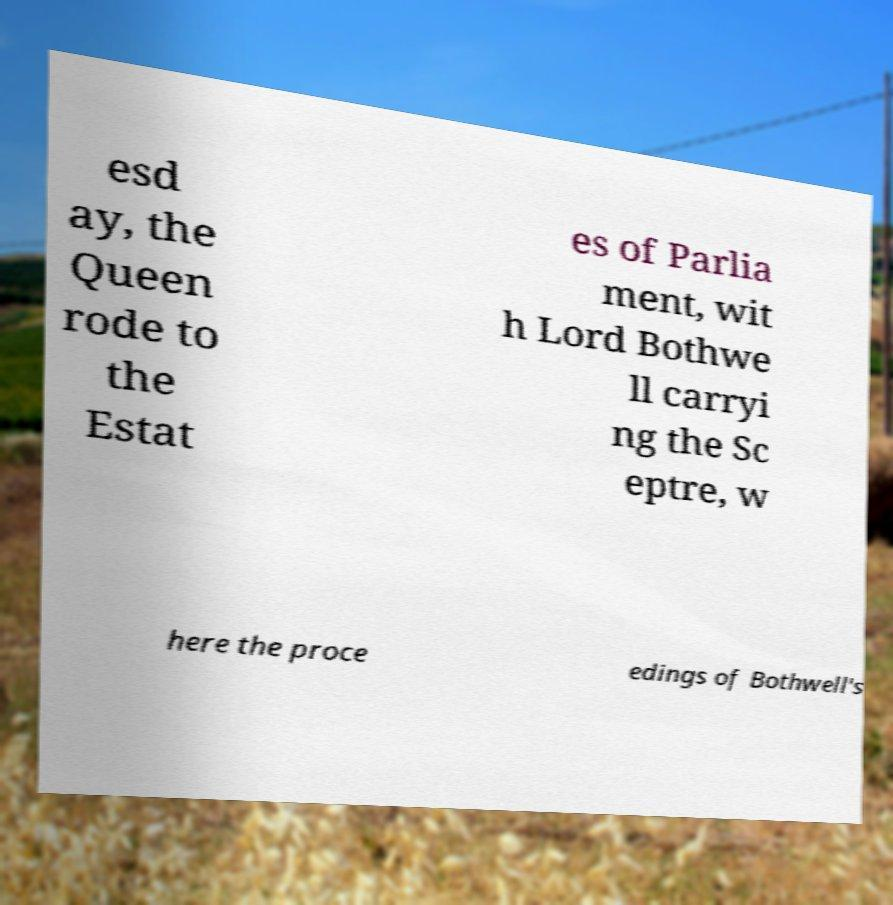Could you extract and type out the text from this image? esd ay, the Queen rode to the Estat es of Parlia ment, wit h Lord Bothwe ll carryi ng the Sc eptre, w here the proce edings of Bothwell's 